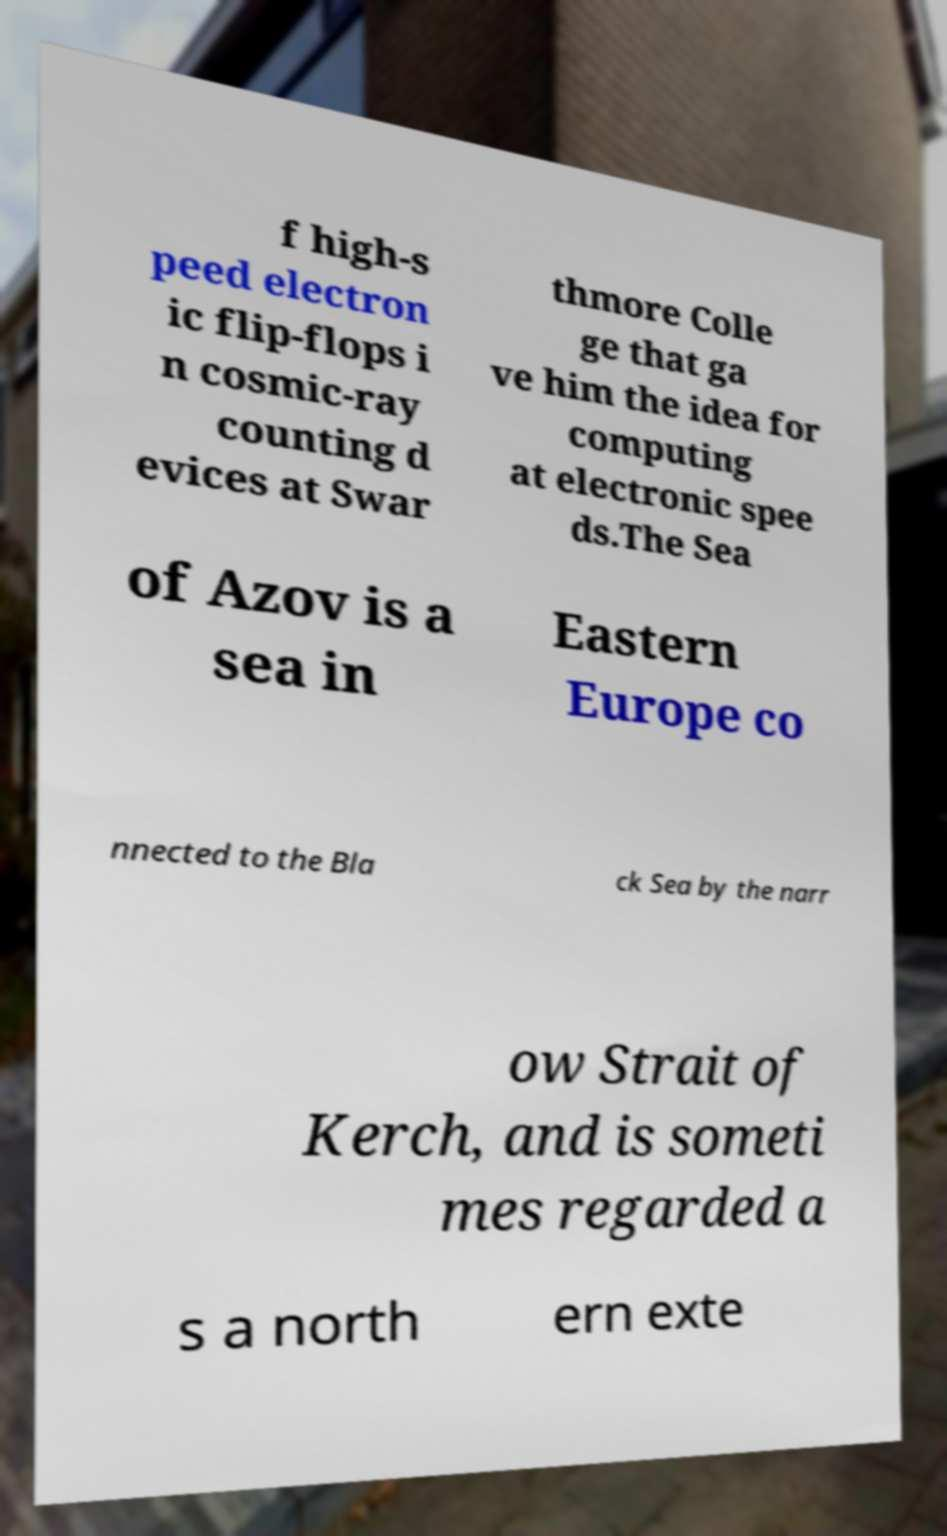Could you assist in decoding the text presented in this image and type it out clearly? f high-s peed electron ic flip-flops i n cosmic-ray counting d evices at Swar thmore Colle ge that ga ve him the idea for computing at electronic spee ds.The Sea of Azov is a sea in Eastern Europe co nnected to the Bla ck Sea by the narr ow Strait of Kerch, and is someti mes regarded a s a north ern exte 